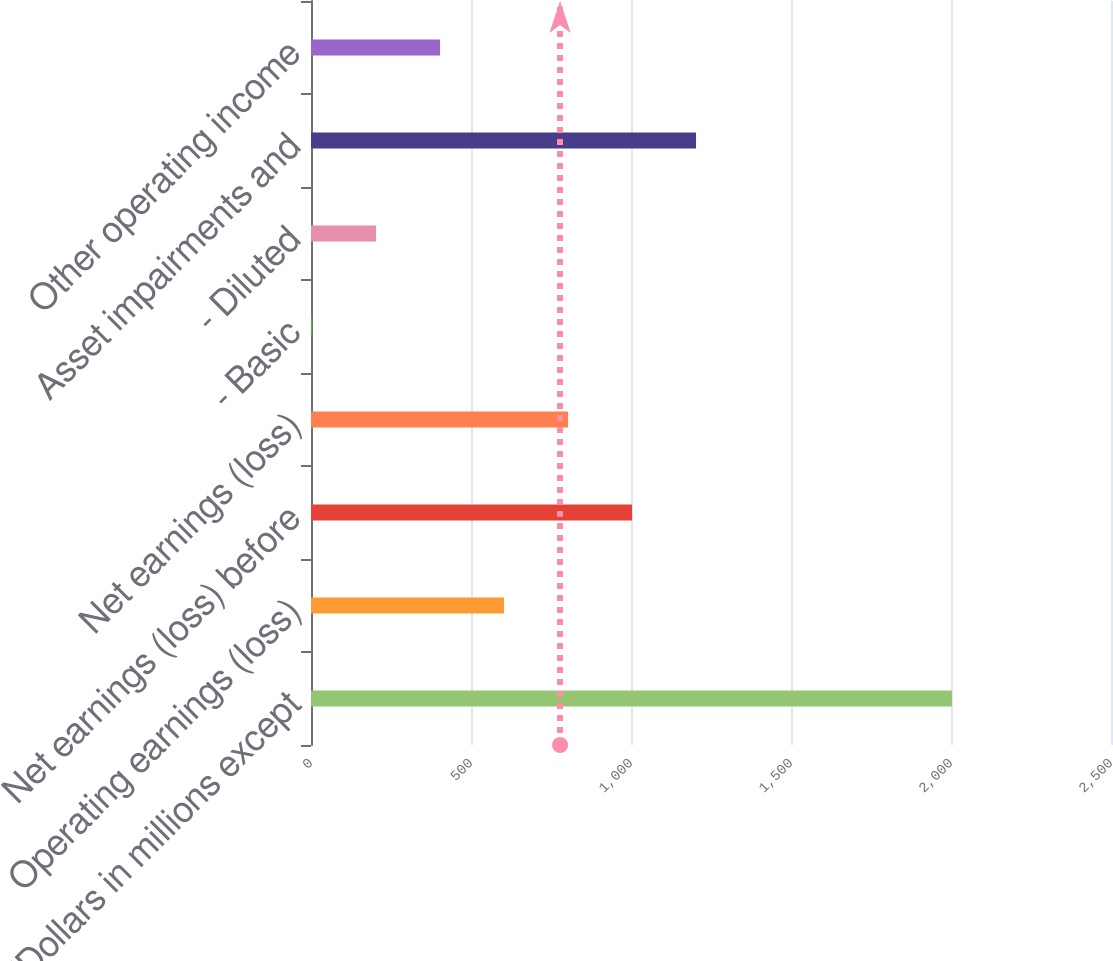Convert chart to OTSL. <chart><loc_0><loc_0><loc_500><loc_500><bar_chart><fcel>(Dollars in millions except<fcel>Operating earnings (loss)<fcel>Net earnings (loss) before<fcel>Net earnings (loss)<fcel>- Basic<fcel>- Diluted<fcel>Asset impairments and<fcel>Other operating income<nl><fcel>2003<fcel>603.35<fcel>1003.25<fcel>803.3<fcel>3.5<fcel>203.45<fcel>1203.2<fcel>403.4<nl></chart> 